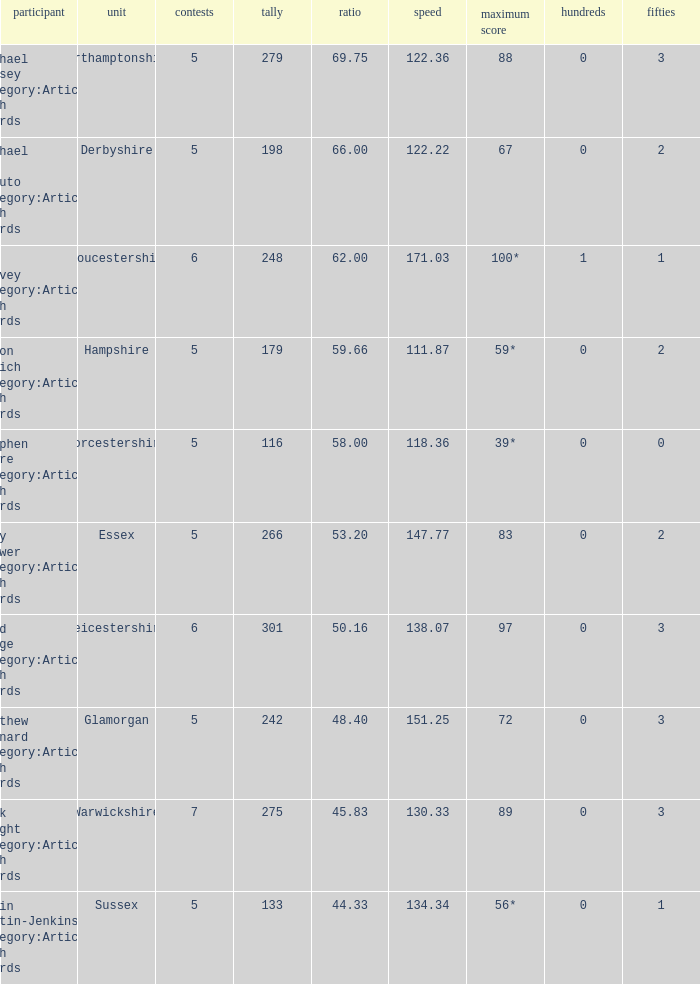If the team is Gloucestershire, what is the average? 62.0. 